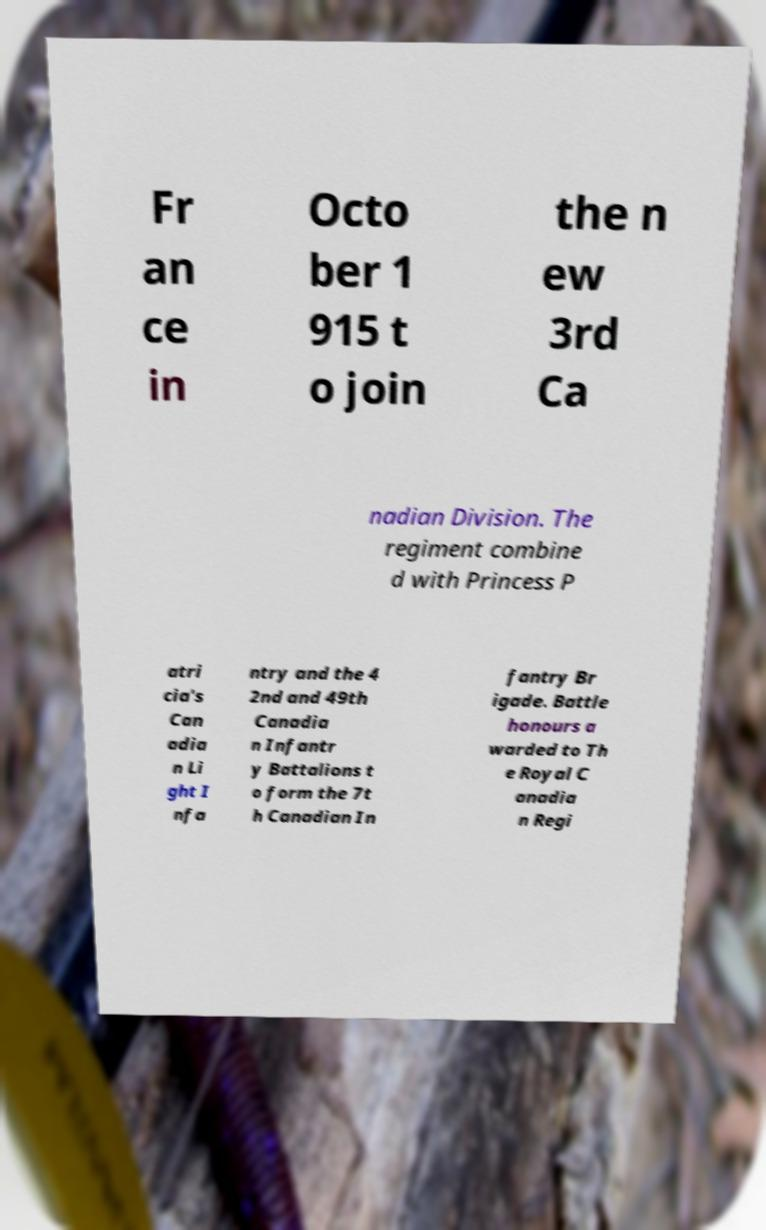I need the written content from this picture converted into text. Can you do that? Fr an ce in Octo ber 1 915 t o join the n ew 3rd Ca nadian Division. The regiment combine d with Princess P atri cia's Can adia n Li ght I nfa ntry and the 4 2nd and 49th Canadia n Infantr y Battalions t o form the 7t h Canadian In fantry Br igade. Battle honours a warded to Th e Royal C anadia n Regi 